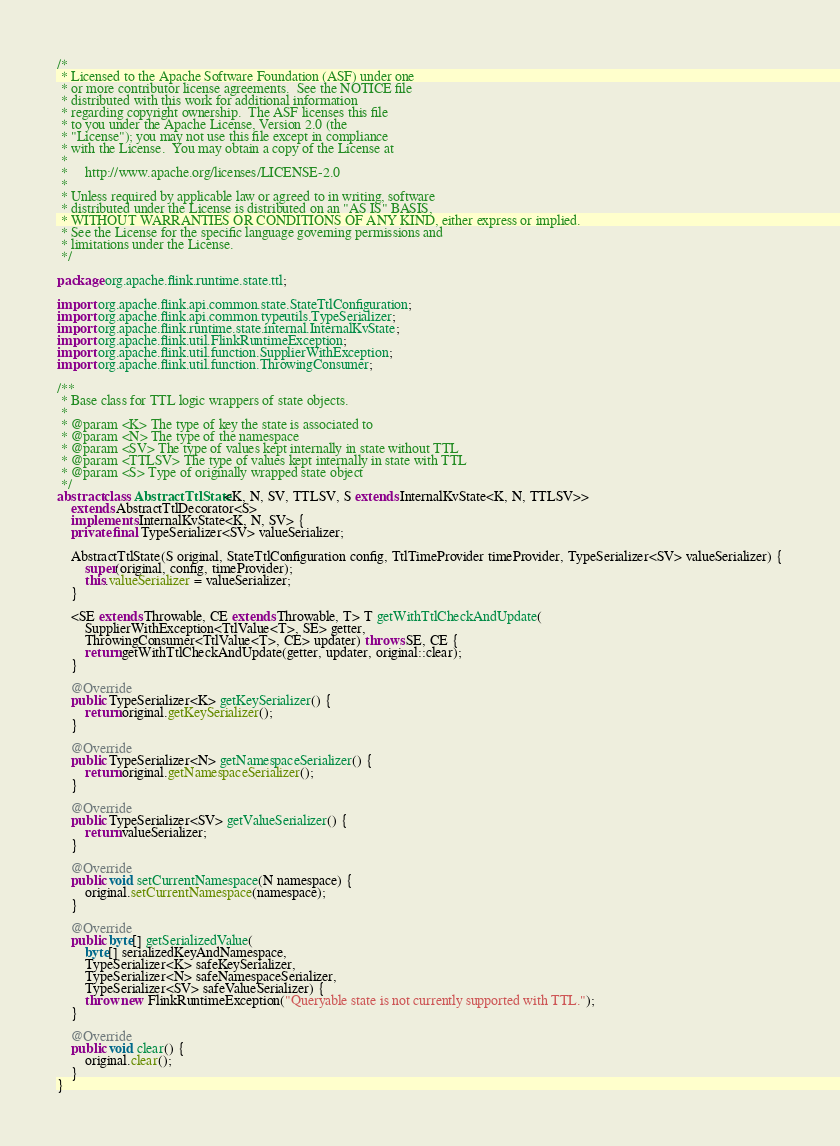Convert code to text. <code><loc_0><loc_0><loc_500><loc_500><_Java_>/*
 * Licensed to the Apache Software Foundation (ASF) under one
 * or more contributor license agreements.  See the NOTICE file
 * distributed with this work for additional information
 * regarding copyright ownership.  The ASF licenses this file
 * to you under the Apache License, Version 2.0 (the
 * "License"); you may not use this file except in compliance
 * with the License.  You may obtain a copy of the License at
 *
 *     http://www.apache.org/licenses/LICENSE-2.0
 *
 * Unless required by applicable law or agreed to in writing, software
 * distributed under the License is distributed on an "AS IS" BASIS,
 * WITHOUT WARRANTIES OR CONDITIONS OF ANY KIND, either express or implied.
 * See the License for the specific language governing permissions and
 * limitations under the License.
 */

package org.apache.flink.runtime.state.ttl;

import org.apache.flink.api.common.state.StateTtlConfiguration;
import org.apache.flink.api.common.typeutils.TypeSerializer;
import org.apache.flink.runtime.state.internal.InternalKvState;
import org.apache.flink.util.FlinkRuntimeException;
import org.apache.flink.util.function.SupplierWithException;
import org.apache.flink.util.function.ThrowingConsumer;

/**
 * Base class for TTL logic wrappers of state objects.
 *
 * @param <K> The type of key the state is associated to
 * @param <N> The type of the namespace
 * @param <SV> The type of values kept internally in state without TTL
 * @param <TTLSV> The type of values kept internally in state with TTL
 * @param <S> Type of originally wrapped state object
 */
abstract class AbstractTtlState<K, N, SV, TTLSV, S extends InternalKvState<K, N, TTLSV>>
	extends AbstractTtlDecorator<S>
	implements InternalKvState<K, N, SV> {
	private final TypeSerializer<SV> valueSerializer;

	AbstractTtlState(S original, StateTtlConfiguration config, TtlTimeProvider timeProvider, TypeSerializer<SV> valueSerializer) {
		super(original, config, timeProvider);
		this.valueSerializer = valueSerializer;
	}

	<SE extends Throwable, CE extends Throwable, T> T getWithTtlCheckAndUpdate(
		SupplierWithException<TtlValue<T>, SE> getter,
		ThrowingConsumer<TtlValue<T>, CE> updater) throws SE, CE {
		return getWithTtlCheckAndUpdate(getter, updater, original::clear);
	}

	@Override
	public TypeSerializer<K> getKeySerializer() {
		return original.getKeySerializer();
	}

	@Override
	public TypeSerializer<N> getNamespaceSerializer() {
		return original.getNamespaceSerializer();
	}

	@Override
	public TypeSerializer<SV> getValueSerializer() {
		return valueSerializer;
	}

	@Override
	public void setCurrentNamespace(N namespace) {
		original.setCurrentNamespace(namespace);
	}

	@Override
	public byte[] getSerializedValue(
		byte[] serializedKeyAndNamespace,
		TypeSerializer<K> safeKeySerializer,
		TypeSerializer<N> safeNamespaceSerializer,
		TypeSerializer<SV> safeValueSerializer) {
		throw new FlinkRuntimeException("Queryable state is not currently supported with TTL.");
	}

	@Override
	public void clear() {
		original.clear();
	}
}
</code> 